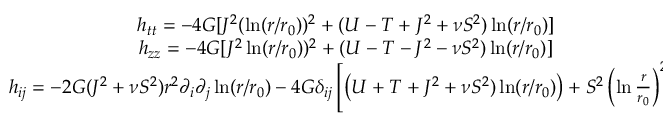<formula> <loc_0><loc_0><loc_500><loc_500>\begin{array} { c c } { { h _ { t t } = - 4 G [ J ^ { 2 } ( \ln ( r / r _ { 0 } ) ) ^ { 2 } + ( U - T + J ^ { 2 } + \nu S ^ { 2 } ) \ln ( r / r _ { 0 } ) ] } } \\ { { h _ { z z } = - 4 G [ J ^ { 2 } \ln ( r / r _ { 0 } ) ) ^ { 2 } + ( U - T - J ^ { 2 } - \nu S ^ { 2 } ) \ln ( r / r _ { 0 } ) ] } } \\ { { h _ { i j } = - 2 G ( J ^ { 2 } + \nu S ^ { 2 } ) r ^ { 2 } \partial _ { i } \partial _ { j } \ln ( r / r _ { 0 } ) - 4 G \delta _ { i j } \left [ \left ( U + T + J ^ { 2 } + \nu S ^ { 2 } ) \ln ( r / r _ { 0 } ) \right ) + S ^ { 2 } \left ( \ln \frac { r } { r _ { 0 } } \right ) ^ { 2 } \right ] . } } \end{array}</formula> 